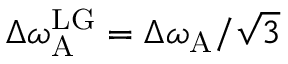Convert formula to latex. <formula><loc_0><loc_0><loc_500><loc_500>\Delta \omega _ { A } ^ { L G } = \Delta \omega _ { A } / \sqrt { 3 }</formula> 